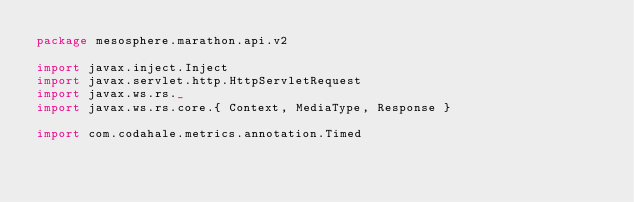<code> <loc_0><loc_0><loc_500><loc_500><_Scala_>package mesosphere.marathon.api.v2

import javax.inject.Inject
import javax.servlet.http.HttpServletRequest
import javax.ws.rs._
import javax.ws.rs.core.{ Context, MediaType, Response }

import com.codahale.metrics.annotation.Timed</code> 